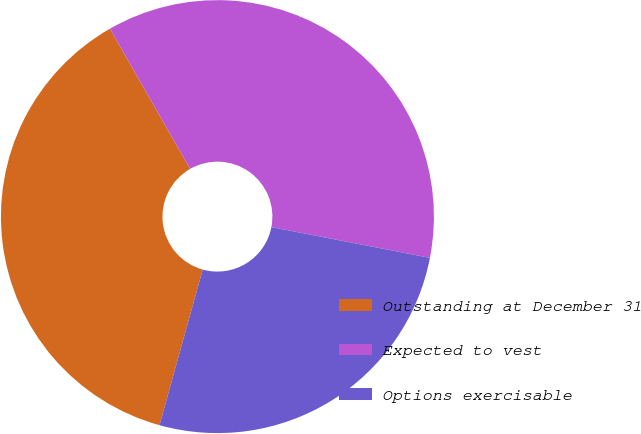Convert chart. <chart><loc_0><loc_0><loc_500><loc_500><pie_chart><fcel>Outstanding at December 31<fcel>Expected to vest<fcel>Options exercisable<nl><fcel>37.41%<fcel>36.32%<fcel>26.26%<nl></chart> 